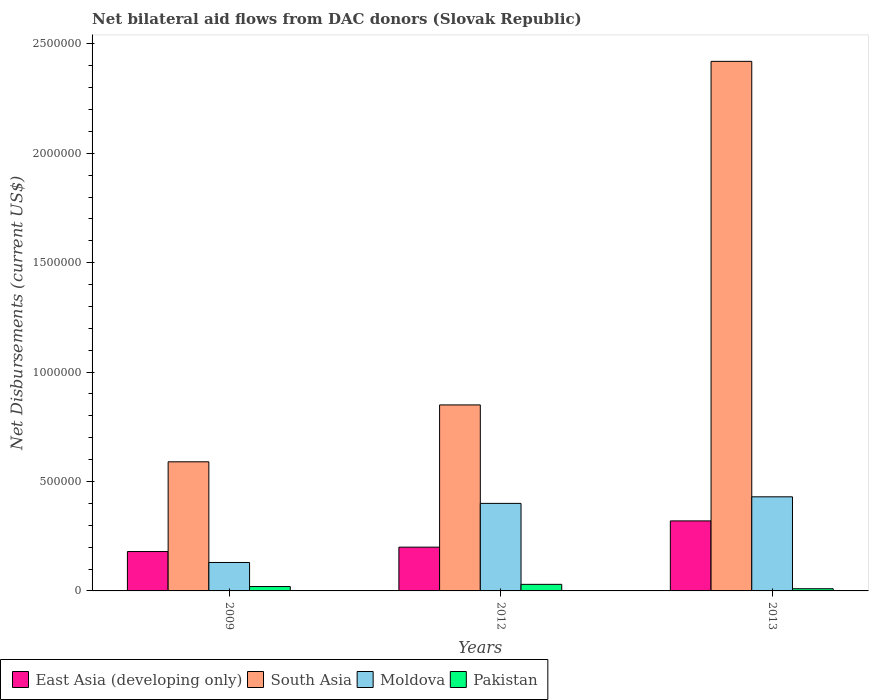How many groups of bars are there?
Your answer should be compact. 3. How many bars are there on the 3rd tick from the right?
Make the answer very short. 4. What is the label of the 1st group of bars from the left?
Ensure brevity in your answer.  2009. In how many cases, is the number of bars for a given year not equal to the number of legend labels?
Keep it short and to the point. 0. What is the net bilateral aid flows in South Asia in 2009?
Provide a short and direct response. 5.90e+05. What is the total net bilateral aid flows in South Asia in the graph?
Your answer should be very brief. 3.86e+06. What is the difference between the net bilateral aid flows in South Asia in 2009 and that in 2012?
Keep it short and to the point. -2.60e+05. What is the difference between the net bilateral aid flows in South Asia in 2012 and the net bilateral aid flows in East Asia (developing only) in 2013?
Provide a succinct answer. 5.30e+05. What is the average net bilateral aid flows in East Asia (developing only) per year?
Your answer should be compact. 2.33e+05. In the year 2012, what is the difference between the net bilateral aid flows in East Asia (developing only) and net bilateral aid flows in Moldova?
Give a very brief answer. -2.00e+05. In how many years, is the net bilateral aid flows in Moldova greater than 400000 US$?
Your answer should be compact. 1. What is the ratio of the net bilateral aid flows in South Asia in 2009 to that in 2013?
Make the answer very short. 0.24. Is the net bilateral aid flows in South Asia in 2012 less than that in 2013?
Offer a very short reply. Yes. Is the difference between the net bilateral aid flows in East Asia (developing only) in 2009 and 2012 greater than the difference between the net bilateral aid flows in Moldova in 2009 and 2012?
Your answer should be very brief. Yes. What is the difference between the highest and the lowest net bilateral aid flows in East Asia (developing only)?
Your answer should be very brief. 1.40e+05. What does the 3rd bar from the left in 2013 represents?
Keep it short and to the point. Moldova. What does the 4th bar from the right in 2009 represents?
Give a very brief answer. East Asia (developing only). How many bars are there?
Give a very brief answer. 12. Are all the bars in the graph horizontal?
Provide a short and direct response. No. Where does the legend appear in the graph?
Ensure brevity in your answer.  Bottom left. How many legend labels are there?
Your answer should be compact. 4. How are the legend labels stacked?
Provide a succinct answer. Horizontal. What is the title of the graph?
Offer a terse response. Net bilateral aid flows from DAC donors (Slovak Republic). Does "Italy" appear as one of the legend labels in the graph?
Your response must be concise. No. What is the label or title of the Y-axis?
Your response must be concise. Net Disbursements (current US$). What is the Net Disbursements (current US$) of South Asia in 2009?
Provide a short and direct response. 5.90e+05. What is the Net Disbursements (current US$) of Moldova in 2009?
Provide a short and direct response. 1.30e+05. What is the Net Disbursements (current US$) in Pakistan in 2009?
Offer a very short reply. 2.00e+04. What is the Net Disbursements (current US$) of East Asia (developing only) in 2012?
Your response must be concise. 2.00e+05. What is the Net Disbursements (current US$) in South Asia in 2012?
Provide a succinct answer. 8.50e+05. What is the Net Disbursements (current US$) of East Asia (developing only) in 2013?
Offer a terse response. 3.20e+05. What is the Net Disbursements (current US$) in South Asia in 2013?
Make the answer very short. 2.42e+06. What is the Net Disbursements (current US$) of Moldova in 2013?
Provide a short and direct response. 4.30e+05. What is the Net Disbursements (current US$) in Pakistan in 2013?
Keep it short and to the point. 10000. Across all years, what is the maximum Net Disbursements (current US$) of East Asia (developing only)?
Your answer should be compact. 3.20e+05. Across all years, what is the maximum Net Disbursements (current US$) of South Asia?
Offer a very short reply. 2.42e+06. Across all years, what is the maximum Net Disbursements (current US$) of Moldova?
Provide a short and direct response. 4.30e+05. Across all years, what is the maximum Net Disbursements (current US$) in Pakistan?
Make the answer very short. 3.00e+04. Across all years, what is the minimum Net Disbursements (current US$) of East Asia (developing only)?
Offer a very short reply. 1.80e+05. Across all years, what is the minimum Net Disbursements (current US$) of South Asia?
Ensure brevity in your answer.  5.90e+05. What is the total Net Disbursements (current US$) in East Asia (developing only) in the graph?
Provide a succinct answer. 7.00e+05. What is the total Net Disbursements (current US$) of South Asia in the graph?
Ensure brevity in your answer.  3.86e+06. What is the total Net Disbursements (current US$) in Moldova in the graph?
Offer a terse response. 9.60e+05. What is the total Net Disbursements (current US$) in Pakistan in the graph?
Your answer should be very brief. 6.00e+04. What is the difference between the Net Disbursements (current US$) in East Asia (developing only) in 2009 and that in 2012?
Provide a succinct answer. -2.00e+04. What is the difference between the Net Disbursements (current US$) in South Asia in 2009 and that in 2012?
Make the answer very short. -2.60e+05. What is the difference between the Net Disbursements (current US$) in Moldova in 2009 and that in 2012?
Provide a short and direct response. -2.70e+05. What is the difference between the Net Disbursements (current US$) in South Asia in 2009 and that in 2013?
Provide a short and direct response. -1.83e+06. What is the difference between the Net Disbursements (current US$) of Moldova in 2009 and that in 2013?
Make the answer very short. -3.00e+05. What is the difference between the Net Disbursements (current US$) of Pakistan in 2009 and that in 2013?
Your response must be concise. 10000. What is the difference between the Net Disbursements (current US$) in South Asia in 2012 and that in 2013?
Your answer should be very brief. -1.57e+06. What is the difference between the Net Disbursements (current US$) in Moldova in 2012 and that in 2013?
Keep it short and to the point. -3.00e+04. What is the difference between the Net Disbursements (current US$) of Pakistan in 2012 and that in 2013?
Offer a very short reply. 2.00e+04. What is the difference between the Net Disbursements (current US$) in East Asia (developing only) in 2009 and the Net Disbursements (current US$) in South Asia in 2012?
Offer a very short reply. -6.70e+05. What is the difference between the Net Disbursements (current US$) in East Asia (developing only) in 2009 and the Net Disbursements (current US$) in Moldova in 2012?
Make the answer very short. -2.20e+05. What is the difference between the Net Disbursements (current US$) of South Asia in 2009 and the Net Disbursements (current US$) of Moldova in 2012?
Offer a terse response. 1.90e+05. What is the difference between the Net Disbursements (current US$) of South Asia in 2009 and the Net Disbursements (current US$) of Pakistan in 2012?
Ensure brevity in your answer.  5.60e+05. What is the difference between the Net Disbursements (current US$) in Moldova in 2009 and the Net Disbursements (current US$) in Pakistan in 2012?
Offer a very short reply. 1.00e+05. What is the difference between the Net Disbursements (current US$) of East Asia (developing only) in 2009 and the Net Disbursements (current US$) of South Asia in 2013?
Make the answer very short. -2.24e+06. What is the difference between the Net Disbursements (current US$) of East Asia (developing only) in 2009 and the Net Disbursements (current US$) of Moldova in 2013?
Your response must be concise. -2.50e+05. What is the difference between the Net Disbursements (current US$) in South Asia in 2009 and the Net Disbursements (current US$) in Moldova in 2013?
Ensure brevity in your answer.  1.60e+05. What is the difference between the Net Disbursements (current US$) in South Asia in 2009 and the Net Disbursements (current US$) in Pakistan in 2013?
Offer a very short reply. 5.80e+05. What is the difference between the Net Disbursements (current US$) in Moldova in 2009 and the Net Disbursements (current US$) in Pakistan in 2013?
Your answer should be compact. 1.20e+05. What is the difference between the Net Disbursements (current US$) in East Asia (developing only) in 2012 and the Net Disbursements (current US$) in South Asia in 2013?
Make the answer very short. -2.22e+06. What is the difference between the Net Disbursements (current US$) of East Asia (developing only) in 2012 and the Net Disbursements (current US$) of Moldova in 2013?
Offer a terse response. -2.30e+05. What is the difference between the Net Disbursements (current US$) in South Asia in 2012 and the Net Disbursements (current US$) in Moldova in 2013?
Give a very brief answer. 4.20e+05. What is the difference between the Net Disbursements (current US$) in South Asia in 2012 and the Net Disbursements (current US$) in Pakistan in 2013?
Ensure brevity in your answer.  8.40e+05. What is the average Net Disbursements (current US$) in East Asia (developing only) per year?
Give a very brief answer. 2.33e+05. What is the average Net Disbursements (current US$) in South Asia per year?
Ensure brevity in your answer.  1.29e+06. What is the average Net Disbursements (current US$) of Pakistan per year?
Provide a short and direct response. 2.00e+04. In the year 2009, what is the difference between the Net Disbursements (current US$) of East Asia (developing only) and Net Disbursements (current US$) of South Asia?
Your answer should be very brief. -4.10e+05. In the year 2009, what is the difference between the Net Disbursements (current US$) of South Asia and Net Disbursements (current US$) of Moldova?
Provide a succinct answer. 4.60e+05. In the year 2009, what is the difference between the Net Disbursements (current US$) of South Asia and Net Disbursements (current US$) of Pakistan?
Offer a very short reply. 5.70e+05. In the year 2009, what is the difference between the Net Disbursements (current US$) of Moldova and Net Disbursements (current US$) of Pakistan?
Ensure brevity in your answer.  1.10e+05. In the year 2012, what is the difference between the Net Disbursements (current US$) in East Asia (developing only) and Net Disbursements (current US$) in South Asia?
Your response must be concise. -6.50e+05. In the year 2012, what is the difference between the Net Disbursements (current US$) in East Asia (developing only) and Net Disbursements (current US$) in Moldova?
Make the answer very short. -2.00e+05. In the year 2012, what is the difference between the Net Disbursements (current US$) in East Asia (developing only) and Net Disbursements (current US$) in Pakistan?
Make the answer very short. 1.70e+05. In the year 2012, what is the difference between the Net Disbursements (current US$) of South Asia and Net Disbursements (current US$) of Moldova?
Your response must be concise. 4.50e+05. In the year 2012, what is the difference between the Net Disbursements (current US$) of South Asia and Net Disbursements (current US$) of Pakistan?
Provide a short and direct response. 8.20e+05. In the year 2012, what is the difference between the Net Disbursements (current US$) in Moldova and Net Disbursements (current US$) in Pakistan?
Your answer should be compact. 3.70e+05. In the year 2013, what is the difference between the Net Disbursements (current US$) in East Asia (developing only) and Net Disbursements (current US$) in South Asia?
Your answer should be compact. -2.10e+06. In the year 2013, what is the difference between the Net Disbursements (current US$) of East Asia (developing only) and Net Disbursements (current US$) of Pakistan?
Offer a terse response. 3.10e+05. In the year 2013, what is the difference between the Net Disbursements (current US$) in South Asia and Net Disbursements (current US$) in Moldova?
Your answer should be very brief. 1.99e+06. In the year 2013, what is the difference between the Net Disbursements (current US$) of South Asia and Net Disbursements (current US$) of Pakistan?
Keep it short and to the point. 2.41e+06. In the year 2013, what is the difference between the Net Disbursements (current US$) of Moldova and Net Disbursements (current US$) of Pakistan?
Your answer should be very brief. 4.20e+05. What is the ratio of the Net Disbursements (current US$) of South Asia in 2009 to that in 2012?
Make the answer very short. 0.69. What is the ratio of the Net Disbursements (current US$) of Moldova in 2009 to that in 2012?
Keep it short and to the point. 0.33. What is the ratio of the Net Disbursements (current US$) in Pakistan in 2009 to that in 2012?
Keep it short and to the point. 0.67. What is the ratio of the Net Disbursements (current US$) of East Asia (developing only) in 2009 to that in 2013?
Offer a terse response. 0.56. What is the ratio of the Net Disbursements (current US$) of South Asia in 2009 to that in 2013?
Ensure brevity in your answer.  0.24. What is the ratio of the Net Disbursements (current US$) of Moldova in 2009 to that in 2013?
Give a very brief answer. 0.3. What is the ratio of the Net Disbursements (current US$) in Pakistan in 2009 to that in 2013?
Your response must be concise. 2. What is the ratio of the Net Disbursements (current US$) in South Asia in 2012 to that in 2013?
Provide a succinct answer. 0.35. What is the ratio of the Net Disbursements (current US$) of Moldova in 2012 to that in 2013?
Provide a short and direct response. 0.93. What is the ratio of the Net Disbursements (current US$) of Pakistan in 2012 to that in 2013?
Your answer should be very brief. 3. What is the difference between the highest and the second highest Net Disbursements (current US$) of East Asia (developing only)?
Provide a short and direct response. 1.20e+05. What is the difference between the highest and the second highest Net Disbursements (current US$) in South Asia?
Your answer should be compact. 1.57e+06. What is the difference between the highest and the second highest Net Disbursements (current US$) in Moldova?
Keep it short and to the point. 3.00e+04. What is the difference between the highest and the second highest Net Disbursements (current US$) in Pakistan?
Provide a succinct answer. 10000. What is the difference between the highest and the lowest Net Disbursements (current US$) of South Asia?
Offer a very short reply. 1.83e+06. What is the difference between the highest and the lowest Net Disbursements (current US$) in Moldova?
Ensure brevity in your answer.  3.00e+05. What is the difference between the highest and the lowest Net Disbursements (current US$) in Pakistan?
Keep it short and to the point. 2.00e+04. 